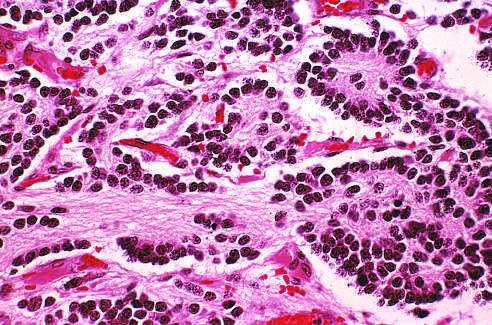s this tumor composed of small cells embedded in a finely fibrillar matrix?
Answer the question using a single word or phrase. Yes 